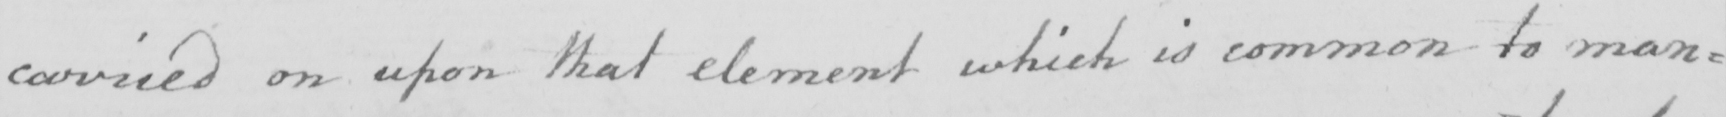What text is written in this handwritten line? carried on upon that element which is common to man= 